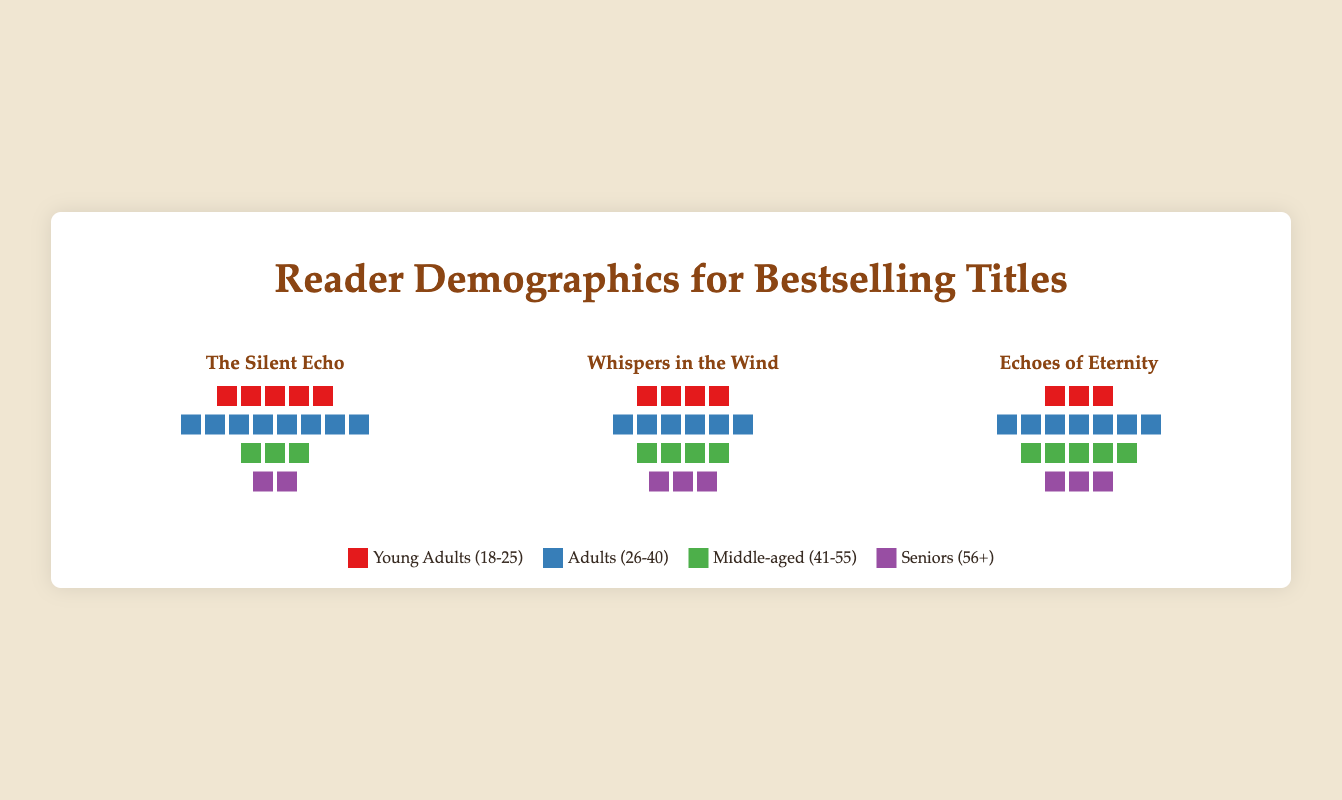How many reader groups are there for each book? Each book has four reader groups. They are: Young Adults (18-25), Adults (26-40), Middle-aged (41-55), and Seniors (56+).
Answer: 4 Which book has the highest percentage of readers among Seniors (56+)? "Whispers in the Wind" has the highest percentage of Seniors (56+) readers. It has 30 seniors out of a total of 170 readers, giving a percentage of 17.6%.
Answer: Whispers in the Wind What is the difference in the count of Middle-aged (41-55) readers between "The Silent Echo" and "Echoes of Eternity"? "The Silent Echo" has 30 Middle-aged readers, while "Echoes of Eternity" has 50. The difference is 50 - 30 = 20.
Answer: 20 Which age group has the largest number of readers for "The Silent Echo"? For "The Silent Echo", the Adults (26-40) group has the largest number of readers with a count of 80.
Answer: Adults (26-40) What is the total number of Young Adults (18-25) readers across all three books? The total number of Young Adults (18-25) readers is calculated by adding the counts from each book: 50 (The Silent Echo) + 40 (Whispers in the Wind) + 30 (Echoes of Eternity) = 120.
Answer: 120 Compare the total number of readers between "The Silent Echo" and "Echoes of Eternity". Which book has more readers and by how much? "The Silent Echo" has a total reader count of 180 (50 + 80 + 30 + 20). "Echoes of Eternity" has a total reader count of 175 (30 + 70 + 50 + 25). "The Silent Echo" has more readers by 180 - 175 = 5.
Answer: The Silent Echo, by 5 What is the average number of readers per group in "Whispers in the Wind"? In "Whispers in the Wind", the total number of readers is 170 (40 + 60 + 40 + 30) and there are four groups. The average number of readers is 170 / 4 = 42.5.
Answer: 42.5 For "Echoes of Eternity", what percentage of its readers are Adults (26-40)? For "Echoes of Eternity", there are 70 Adults (26-40) out of a total of 175 readers. The percentage is (70 / 175) * 100 = 40%.
Answer: 40% Which book has the smallest count of Young Adults (18-25) readers? "Echoes of Eternity" has the smallest count of Young Adults (18-25) readers with a count of 30.
Answer: Echoes of Eternity 